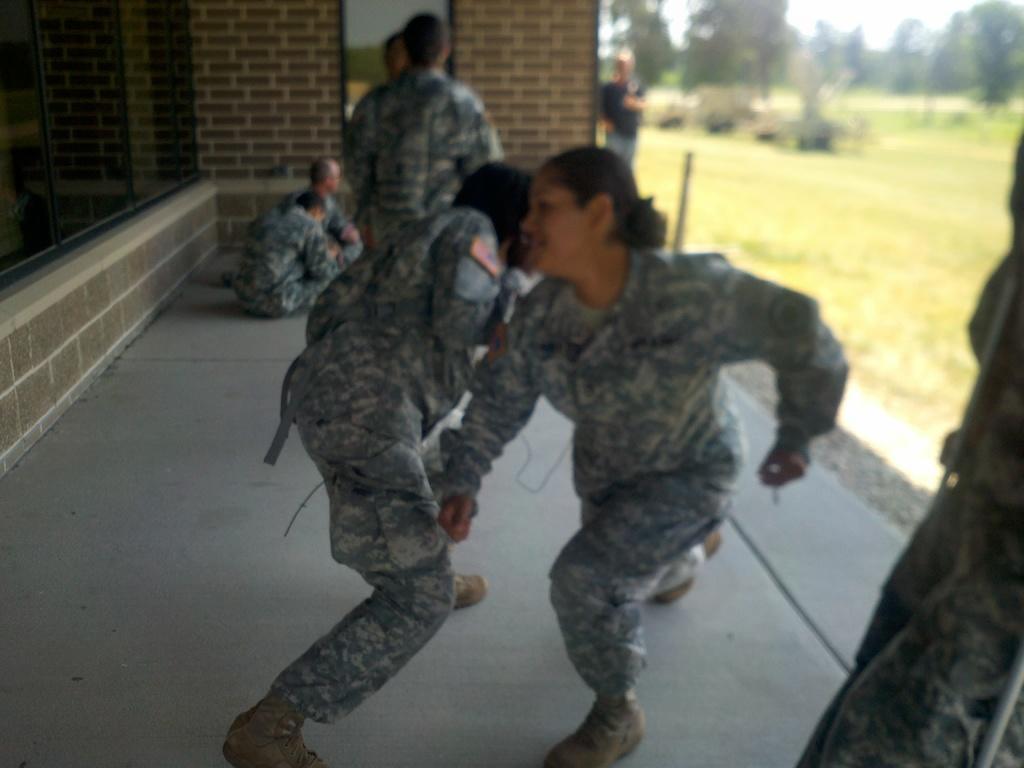Please provide a concise description of this image. In this image we can see a group of people wearing military uniform, and a few among them are sitting on the ground, behind them there is a wall, on the right side of the image we can see some trees and plants. 